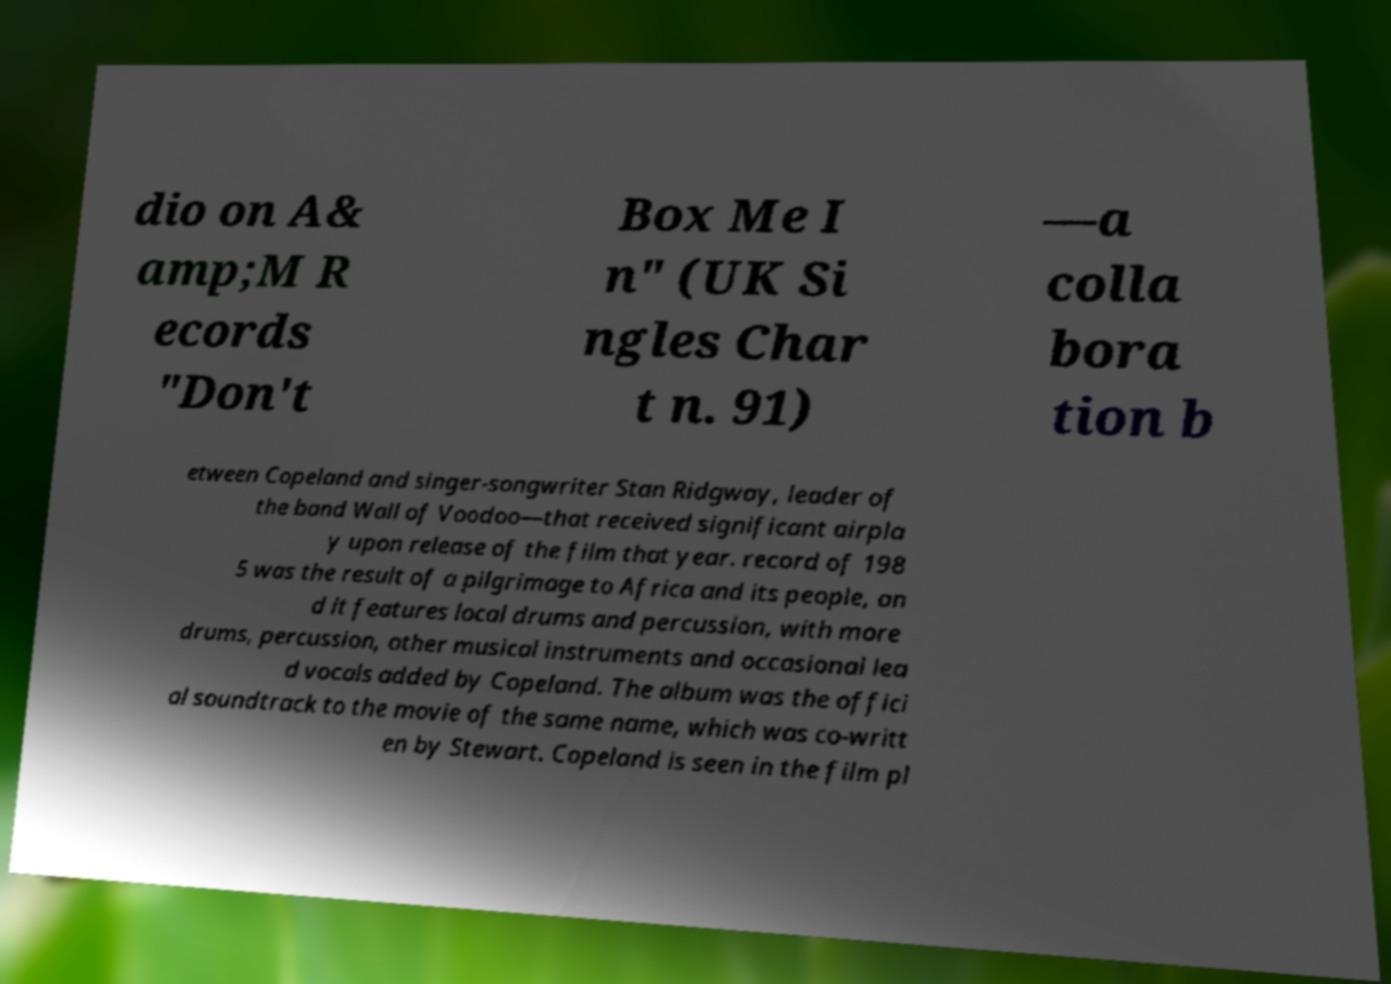Please read and relay the text visible in this image. What does it say? dio on A& amp;M R ecords "Don't Box Me I n" (UK Si ngles Char t n. 91) —a colla bora tion b etween Copeland and singer-songwriter Stan Ridgway, leader of the band Wall of Voodoo—that received significant airpla y upon release of the film that year. record of 198 5 was the result of a pilgrimage to Africa and its people, an d it features local drums and percussion, with more drums, percussion, other musical instruments and occasional lea d vocals added by Copeland. The album was the offici al soundtrack to the movie of the same name, which was co-writt en by Stewart. Copeland is seen in the film pl 